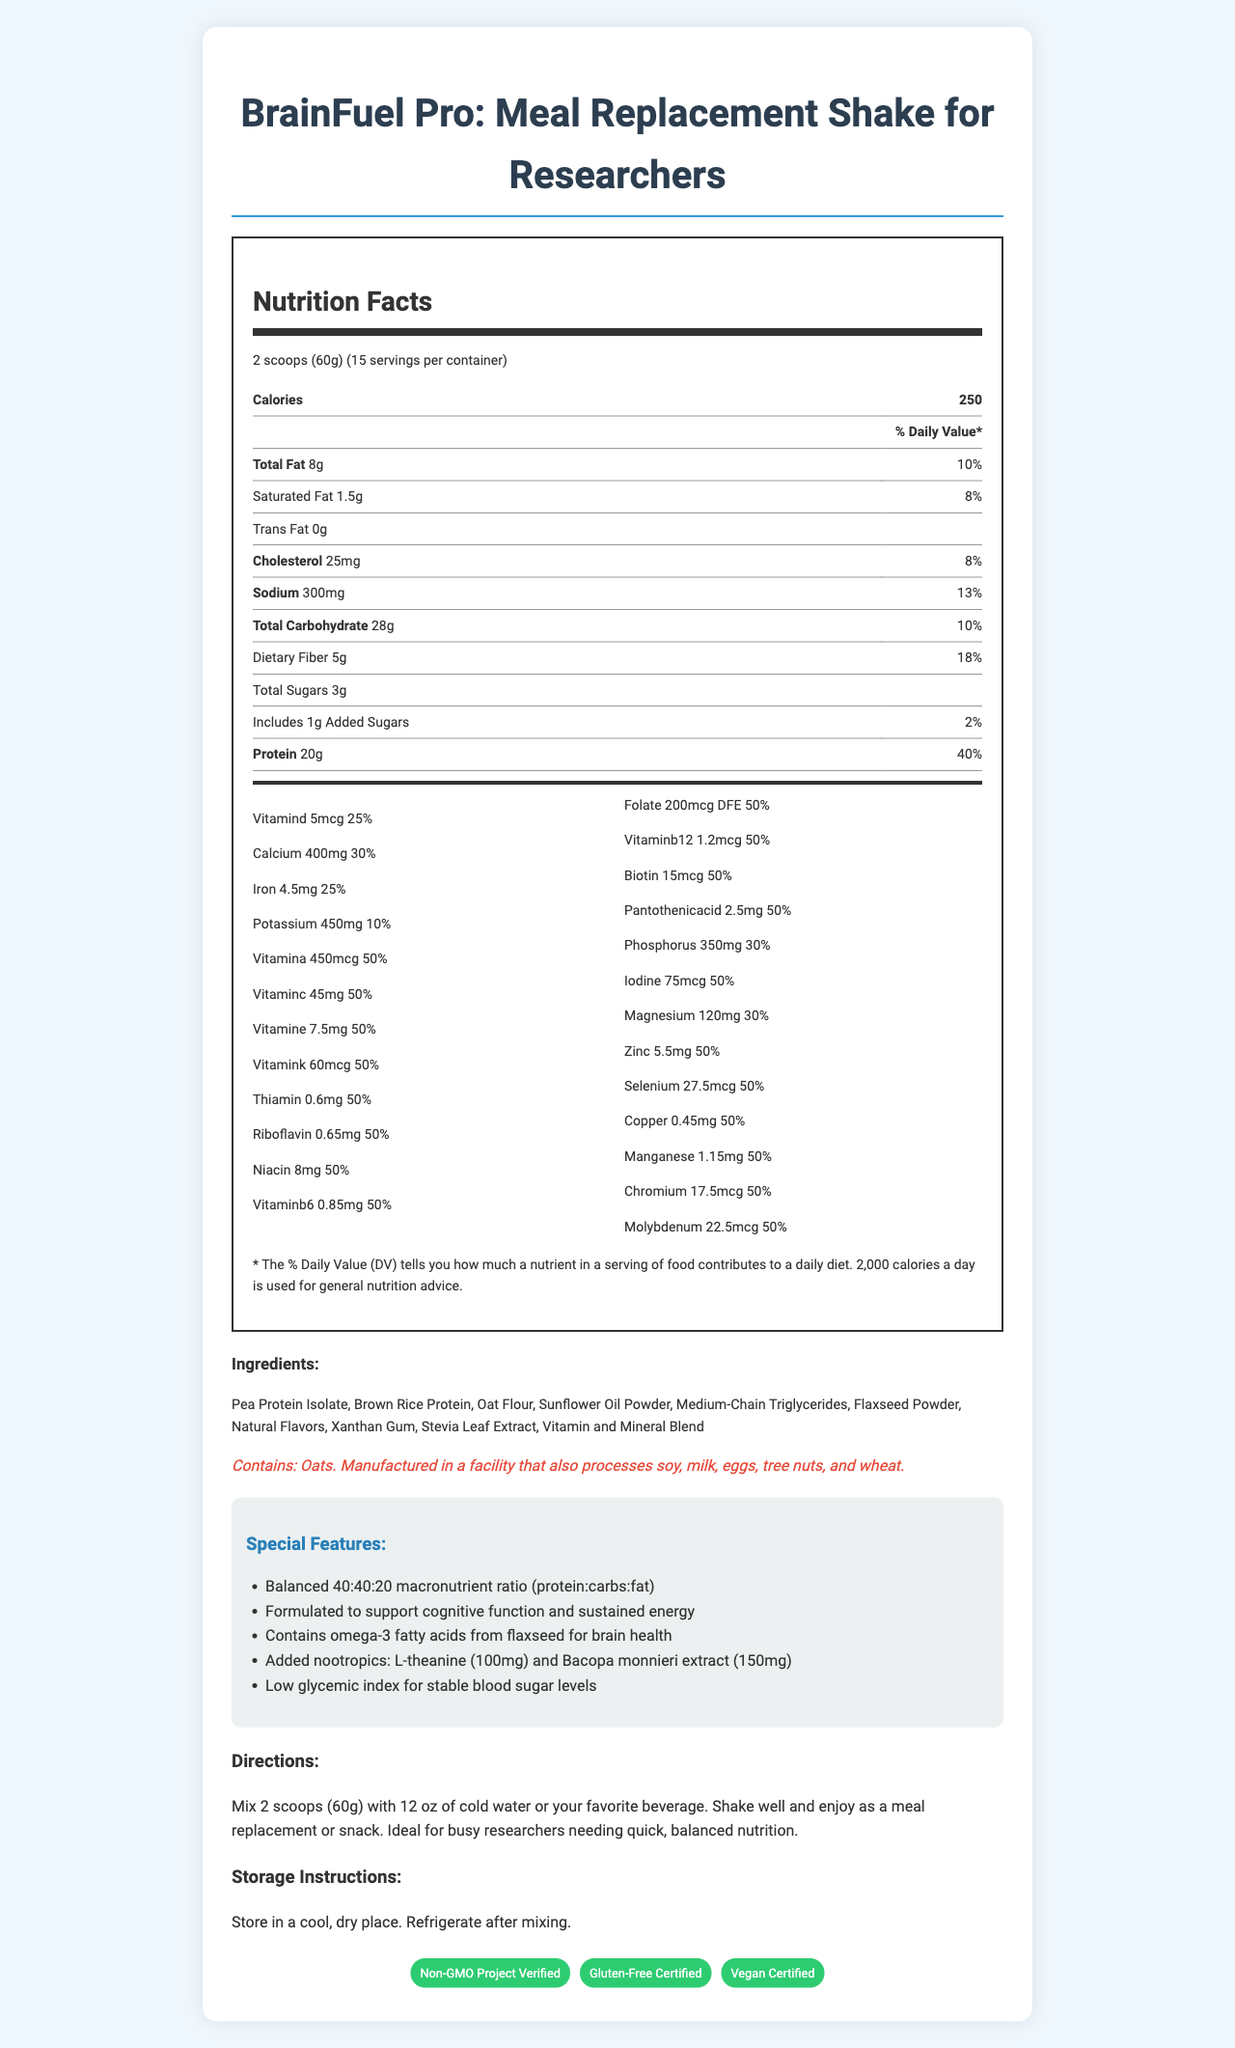what is the serving size of BrainFuel Pro? The document specifies that the serving size for BrainFuel Pro is 2 scoops, which corresponds to 60 grams.
Answer: 2 scoops (60g) how many servings are in one container? The nutrition facts section mentions there are 15 servings per container.
Answer: 15 how many calories are in one serving? The document lists the calories per serving as 250.
Answer: 250 what is the amount of protein in one serving? According to the nutrition facts, each serving contains 20 grams of protein.
Answer: 20g what are the main sources of protein listed in the ingredients? The ingredients section lists Pea Protein Isolate and Brown Rice Protein as the main sources of protein.
Answer: Pea Protein Isolate, Brown Rice Protein which vitamin has the highest daily value percentage? A. Vitamin A B. Vitamin C C. Vitamin D D. Vitamin E The percentage daily value for Vitamin A is 50%, which is the highest among the options provided.
Answer: A. Vitamin A which ingredient provides omega-3 fatty acids for brain health? A. Oat Flour B. Flaxseed Powder C. Medium-Chain Triglycerides D. Natural Flavors The special features section mentions that Flaxseed Powder provides omega-3 fatty acids for brain health.
Answer: B. Flaxseed Powder does BrainFuel Pro contain any trans fat? The nutrition label indicates that the product contains 0g of trans fat.
Answer: No is BrainFuel Pro certified gluten-free? The certifications section mentions that BrainFuel Pro is "Gluten-Free Certified".
Answer: Yes summarize the main goal of BrainFuel Pro. The main goal of BrainFuel Pro is outlined in the product description and special features, which focus on providing researchers with balanced nutrition and cognitive support.
Answer: BrainFuel Pro is designed as a meal replacement shake specifically tailored to busy researchers, offering balanced nutrition with a 40:40:20 macronutrient ratio to support cognitive function and sustained energy. It also features omega-3 fatty acids, nootropics, and various vitamins and minerals. what is the purpose of L-theanine and Bacopa monnieri extract in this shake? The special features section states the inclusion of L-theanine (100mg) and Bacopa monnieri extract (150mg) to support cognitive function and sustained energy.
Answer: To support cognitive function and sustained energy how much dietary fiber is in one serving? The nutrition facts indicate that one serving contains 5 grams of dietary fiber.
Answer: 5g can I determine the amino acid profile of the protein in BrainFuel Pro from this document? The document does not provide detailed information about the amino acid profile of the protein content.
Answer: Cannot be determined 